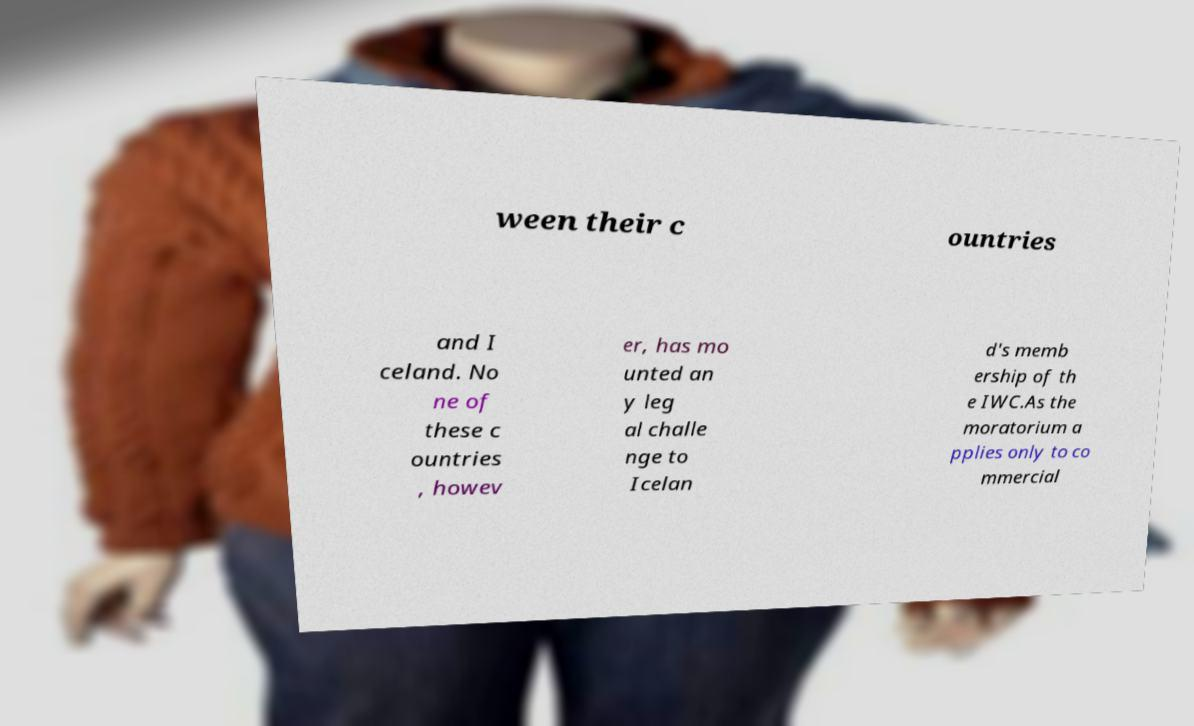Can you accurately transcribe the text from the provided image for me? ween their c ountries and I celand. No ne of these c ountries , howev er, has mo unted an y leg al challe nge to Icelan d's memb ership of th e IWC.As the moratorium a pplies only to co mmercial 